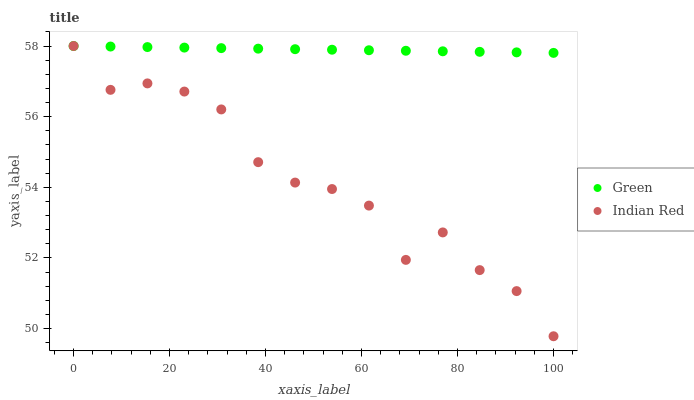Does Indian Red have the minimum area under the curve?
Answer yes or no. Yes. Does Green have the maximum area under the curve?
Answer yes or no. Yes. Does Indian Red have the maximum area under the curve?
Answer yes or no. No. Is Green the smoothest?
Answer yes or no. Yes. Is Indian Red the roughest?
Answer yes or no. Yes. Is Indian Red the smoothest?
Answer yes or no. No. Does Indian Red have the lowest value?
Answer yes or no. Yes. Does Indian Red have the highest value?
Answer yes or no. Yes. Does Indian Red intersect Green?
Answer yes or no. Yes. Is Indian Red less than Green?
Answer yes or no. No. Is Indian Red greater than Green?
Answer yes or no. No. 